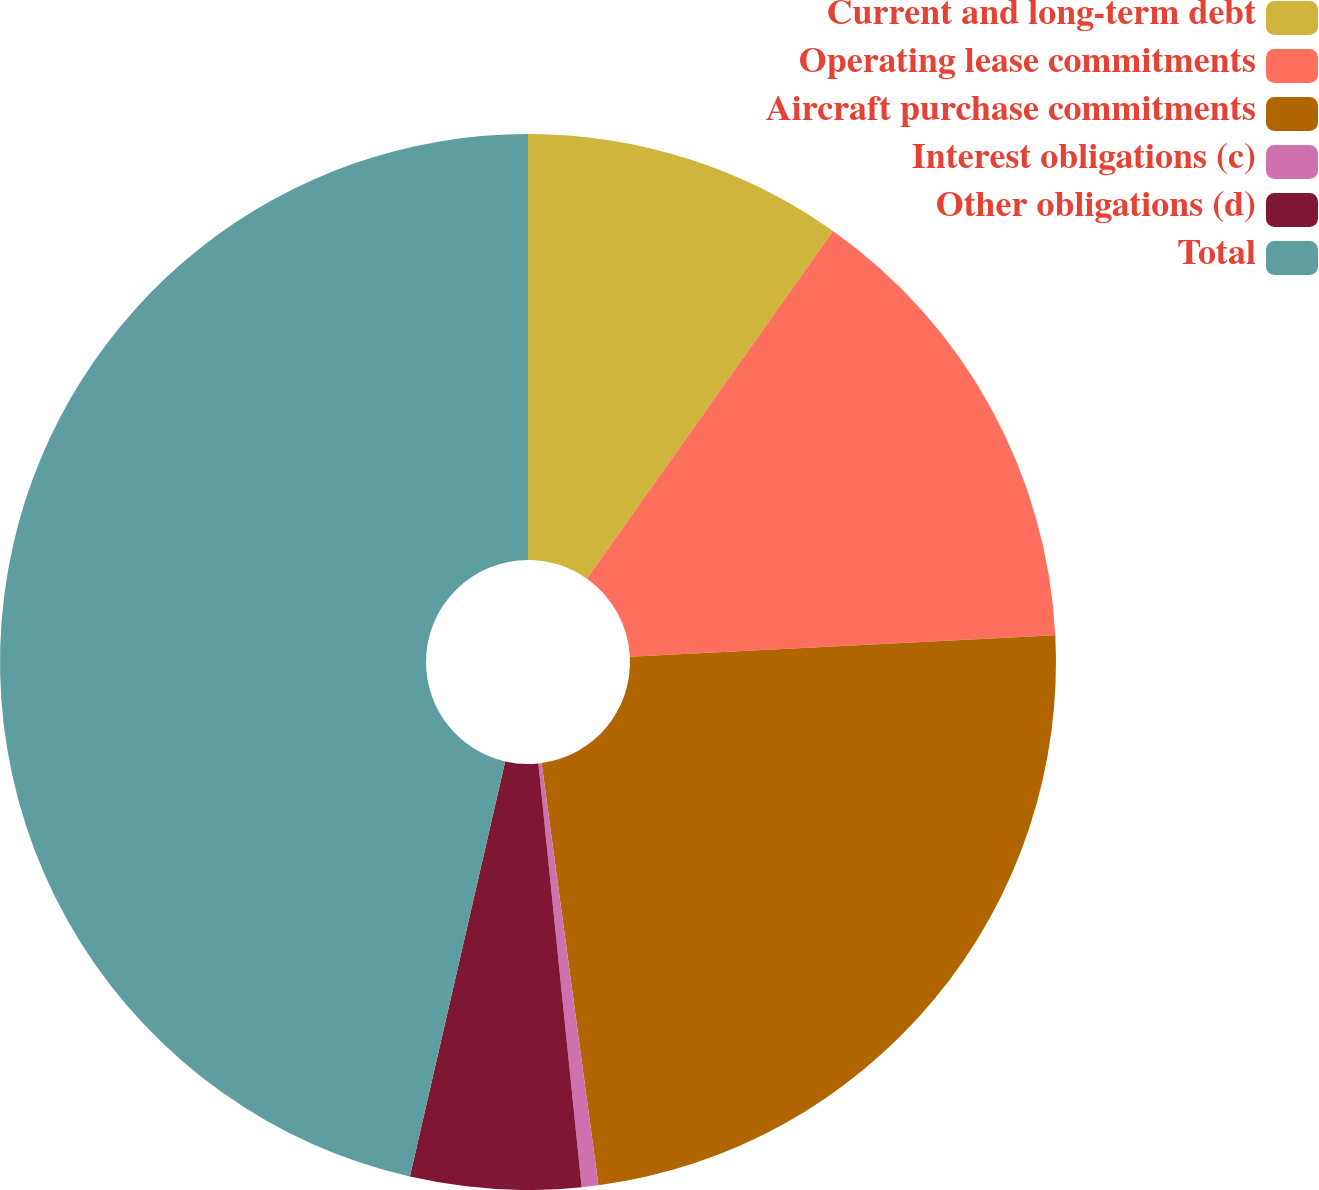<chart> <loc_0><loc_0><loc_500><loc_500><pie_chart><fcel>Current and long-term debt<fcel>Operating lease commitments<fcel>Aircraft purchase commitments<fcel>Interest obligations (c)<fcel>Other obligations (d)<fcel>Total<nl><fcel>9.8%<fcel>14.39%<fcel>23.68%<fcel>0.51%<fcel>5.21%<fcel>46.41%<nl></chart> 